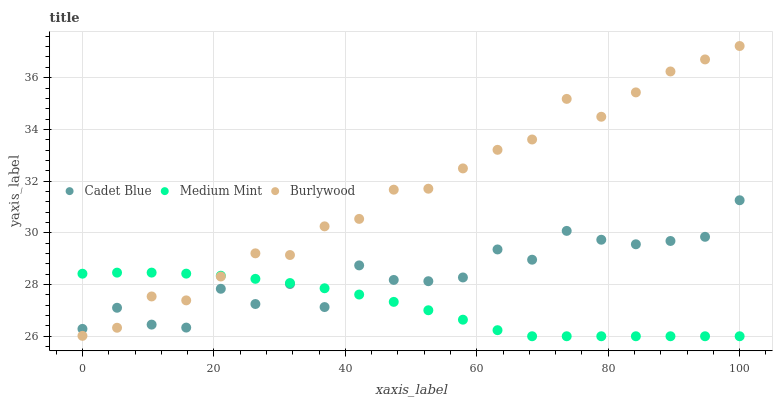Does Medium Mint have the minimum area under the curve?
Answer yes or no. Yes. Does Burlywood have the maximum area under the curve?
Answer yes or no. Yes. Does Cadet Blue have the minimum area under the curve?
Answer yes or no. No. Does Cadet Blue have the maximum area under the curve?
Answer yes or no. No. Is Medium Mint the smoothest?
Answer yes or no. Yes. Is Cadet Blue the roughest?
Answer yes or no. Yes. Is Burlywood the smoothest?
Answer yes or no. No. Is Burlywood the roughest?
Answer yes or no. No. Does Medium Mint have the lowest value?
Answer yes or no. Yes. Does Burlywood have the lowest value?
Answer yes or no. No. Does Burlywood have the highest value?
Answer yes or no. Yes. Does Cadet Blue have the highest value?
Answer yes or no. No. Does Cadet Blue intersect Medium Mint?
Answer yes or no. Yes. Is Cadet Blue less than Medium Mint?
Answer yes or no. No. Is Cadet Blue greater than Medium Mint?
Answer yes or no. No. 